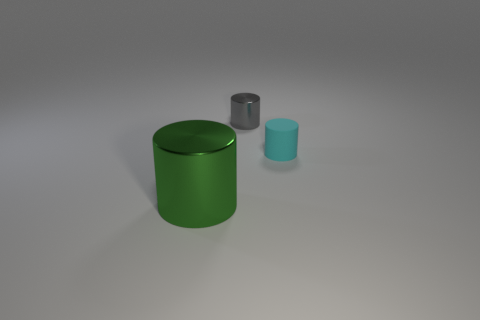Is the material of the tiny thing right of the gray object the same as the small object on the left side of the cyan matte cylinder?
Provide a succinct answer. No. What size is the object that is on the left side of the small cyan cylinder and to the right of the green metallic cylinder?
Ensure brevity in your answer.  Small. What is the material of the gray cylinder that is the same size as the cyan cylinder?
Provide a short and direct response. Metal. What number of tiny gray shiny objects are on the right side of the small cylinder that is in front of the metallic object right of the big metal cylinder?
Your answer should be very brief. 0. There is a metal cylinder that is behind the large shiny cylinder; does it have the same color as the small object in front of the tiny gray object?
Make the answer very short. No. What color is the thing that is on the right side of the large green metallic cylinder and in front of the tiny gray cylinder?
Make the answer very short. Cyan. What number of green metal cylinders are the same size as the cyan cylinder?
Provide a succinct answer. 0. There is a shiny thing on the left side of the metal cylinder that is behind the small cyan object; what is its shape?
Your response must be concise. Cylinder. What shape is the thing that is to the right of the object behind the small matte object that is in front of the gray cylinder?
Give a very brief answer. Cylinder. What number of other metal objects have the same shape as the green shiny object?
Make the answer very short. 1. 